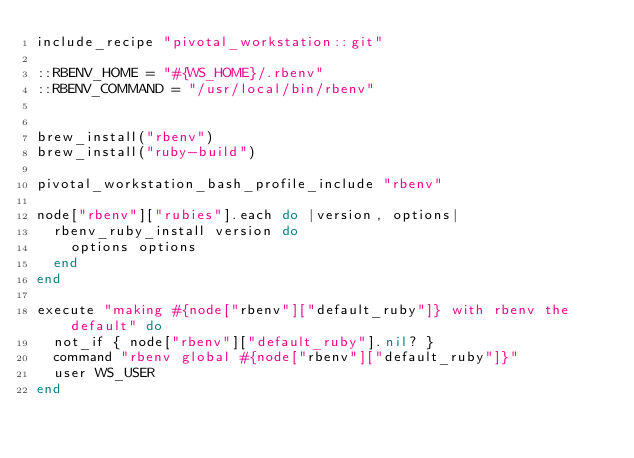<code> <loc_0><loc_0><loc_500><loc_500><_Ruby_>include_recipe "pivotal_workstation::git"

::RBENV_HOME = "#{WS_HOME}/.rbenv"
::RBENV_COMMAND = "/usr/local/bin/rbenv"


brew_install("rbenv")
brew_install("ruby-build")

pivotal_workstation_bash_profile_include "rbenv"

node["rbenv"]["rubies"].each do |version, options|
  rbenv_ruby_install version do
    options options
  end
end

execute "making #{node["rbenv"]["default_ruby"]} with rbenv the default" do
  not_if { node["rbenv"]["default_ruby"].nil? }
  command "rbenv global #{node["rbenv"]["default_ruby"]}"
  user WS_USER
end
</code> 